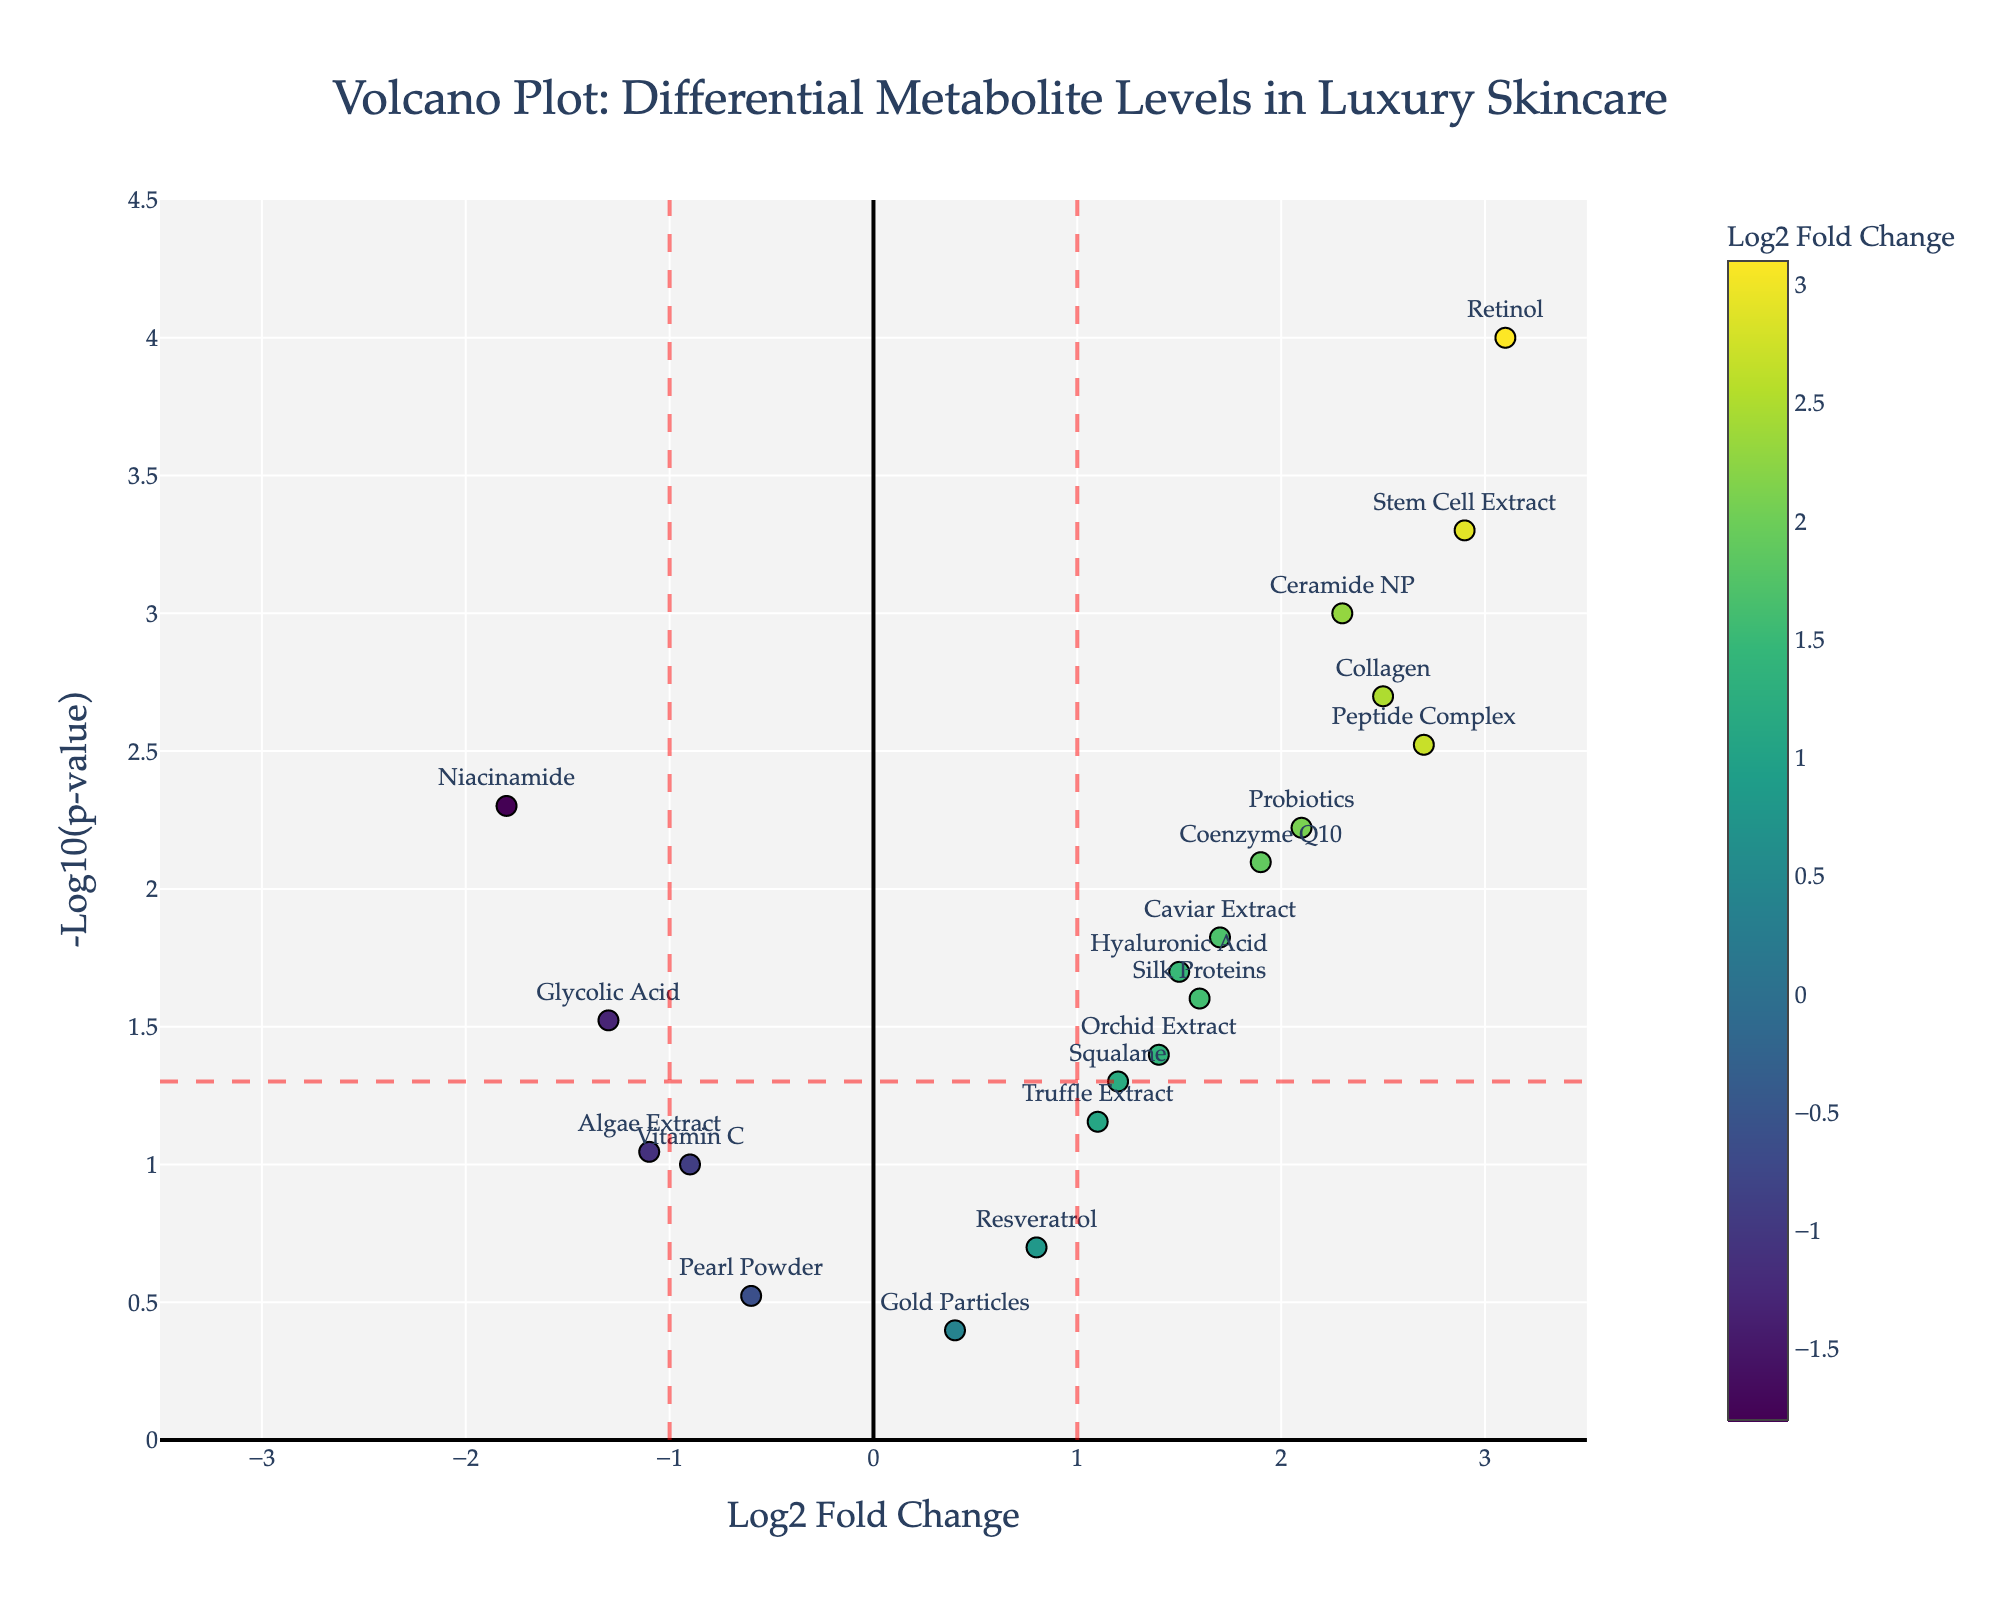What is the title of the plot? The title is positioned at the top and reads "Volcano Plot: Differential Metabolite Levels in Luxury Skincare"
Answer: Volcano Plot: Differential Metabolite Levels in Luxury Skincare What do the colors of the markers represent? The colors of the markers represent the Log2 Fold Change values of the metabolites, with a color scale shown on the right of the plot
Answer: Log2 Fold Change values Which metabolites have a p-value below 0.05? To identify metabolites with a p-value below 0.05, locate the markers above the horizontal red dashed line (-log10(0.05)). The relevant metabolites are Ceramide NP, Niacinamide, Hyaluronic Acid, Retinol, Peptide Complex, Coenzyme Q10, Collagen, Caviar Extract, Probiotics, and Stem Cell Extract
Answer: Ceramide NP, Niacinamide, Hyaluronic Acid, Retinol, Peptide Complex, Coenzyme Q10, Collagen, Caviar Extract, Probiotics, Stem Cell Extract What is the log2 fold change and p-value for Retinol? Retinol's marker is labeled, positioned at (3.1, 4.0) on the plot. The hover text confirms these values as Log2 Fold Change: 3.1 and p-value: 0.0001
Answer: Log2 Fold Change: 3.1, p-value: 0.0001 Which metabolite has the highest log2 fold change? Identify the marker farthest to the right (highest log2 fold change) and labeled Retinol
Answer: Retinol How many metabolites have a log2 fold change greater than 1 and a p-value less than 0.05? Identify markers to the right of the vertical red dashed line at 1 and above the horizontal red dashed line (-log10(0.05)). These metabolites are Retinol, Probiotics, Peptide Complex, Coenzyme Q10, Stem Cell Extract, Caviar Extract, Ceramide NP, and Collagen. Count these markers
Answer: 8 Compare the log2 fold changes of Ceramide NP and Niacinamide. Which one is higher? Locate both markers on the plot. Ceramide NP has a log2 fold change of 2.3, whereas Niacinamide has -1.8. Ceramide NP has the higher log2 fold change
Answer: Ceramide NP Which metabolite has the smallest -log10(p-value)? Find the marker lowest on the plot. This marker corresponds to Gold Particles with a value of -log10(p-value) = 0.4
Answer: Gold Particles Are there any metabolites with both a negative log2 fold change and a p-value less than 0.05? Locate markers to the left of the vertical red dashed line at -1 and above the horizontal red dashed line (-log10(0.05)). The metabolite Niacinamide meets these criteria
Answer: Niacinamide 